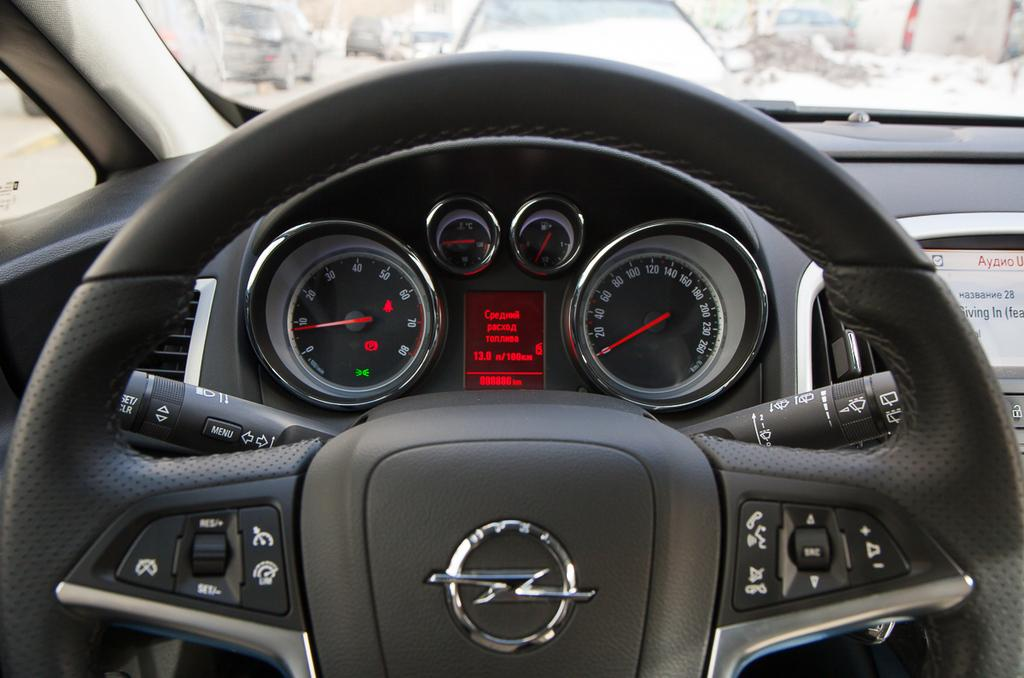What type of vehicles can be seen in the image? There are cars in the image. What is the primary control mechanism for the cars? There is a steering wheel in the image. What feature is present for controlling the temperature inside the cars? There are air conditioning controls in the image. How can the speed of the cars be monitored? There is a speedometer in the image. What device is used for displaying information in the cars? There is a digital screen in the image. What type of interactive elements are present in the cars? There are buttons in the image. How many boys are playing with the squirrel in the image? There are no boys or squirrels present in the image; it features cars with various controls and features. 